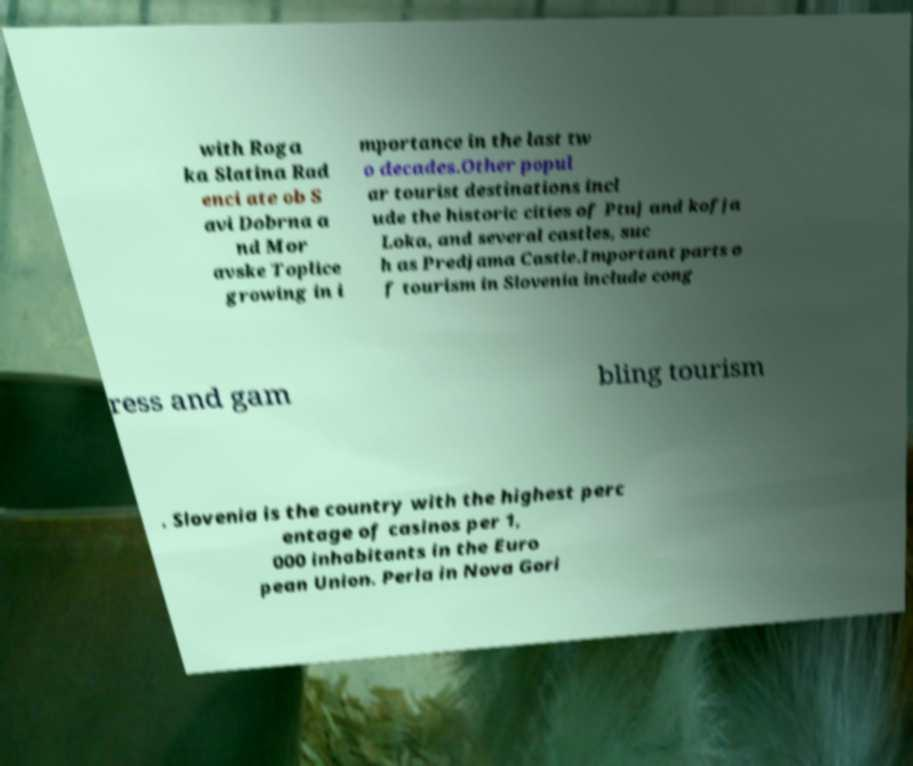For documentation purposes, I need the text within this image transcribed. Could you provide that? with Roga ka Slatina Rad enci ate ob S avi Dobrna a nd Mor avske Toplice growing in i mportance in the last tw o decades.Other popul ar tourist destinations incl ude the historic cities of Ptuj and kofja Loka, and several castles, suc h as Predjama Castle.Important parts o f tourism in Slovenia include cong ress and gam bling tourism . Slovenia is the country with the highest perc entage of casinos per 1, 000 inhabitants in the Euro pean Union. Perla in Nova Gori 